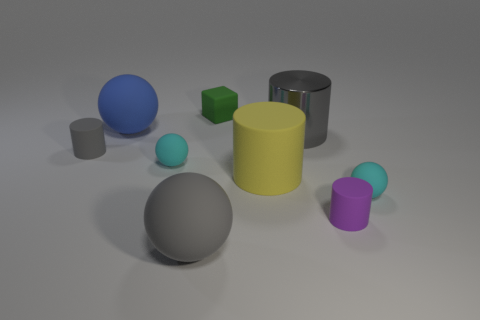What is the size of the cyan rubber thing that is in front of the small cyan rubber object on the left side of the green matte thing?
Keep it short and to the point. Small. What number of other small green objects are the same material as the green thing?
Offer a very short reply. 0. Are there any small gray rubber cylinders?
Offer a terse response. Yes. There is a gray rubber thing in front of the purple cylinder; what size is it?
Your response must be concise. Large. How many large balls have the same color as the matte block?
Your answer should be compact. 0. What number of cubes are big objects or large blue rubber objects?
Provide a succinct answer. 0. The object that is both behind the tiny purple rubber thing and in front of the big yellow rubber cylinder has what shape?
Offer a very short reply. Sphere. Is there a green block of the same size as the gray shiny thing?
Provide a succinct answer. No. What number of objects are either gray cylinders that are to the left of the blue ball or large blue matte objects?
Offer a terse response. 2. Is the big blue thing made of the same material as the small cyan sphere that is behind the large yellow thing?
Provide a succinct answer. Yes. 